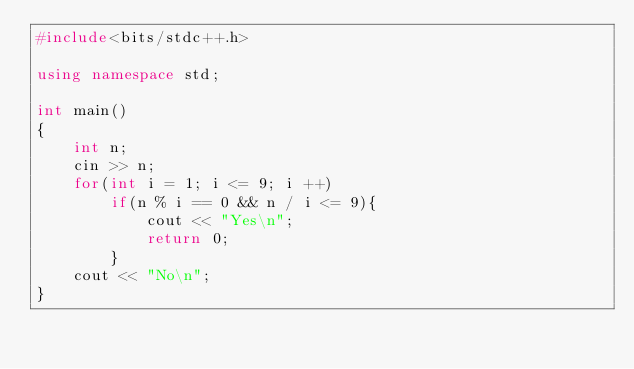<code> <loc_0><loc_0><loc_500><loc_500><_C++_>#include<bits/stdc++.h>

using namespace std;

int main()
{
    int n;
    cin >> n;
    for(int i = 1; i <= 9; i ++)
        if(n % i == 0 && n / i <= 9){
            cout << "Yes\n";
            return 0;
        }
    cout << "No\n";
}
</code> 